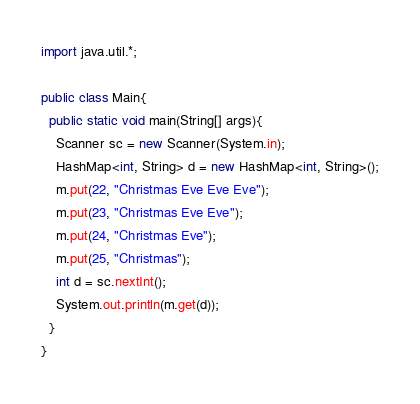<code> <loc_0><loc_0><loc_500><loc_500><_Java_>import java.util.*;

public class Main{
  public static void main(String[] args){
    Scanner sc = new Scanner(System.in);
    HashMap<int, String> d = new HashMap<int, String>();
    m.put(22, "Christmas Eve Eve Eve");
    m.put(23, "Christmas Eve Eve");
    m.put(24, "Christmas Eve");
    m.put(25, "Christmas");
    int d = sc.nextInt();
    System.out.println(m.get(d));
  }
}</code> 